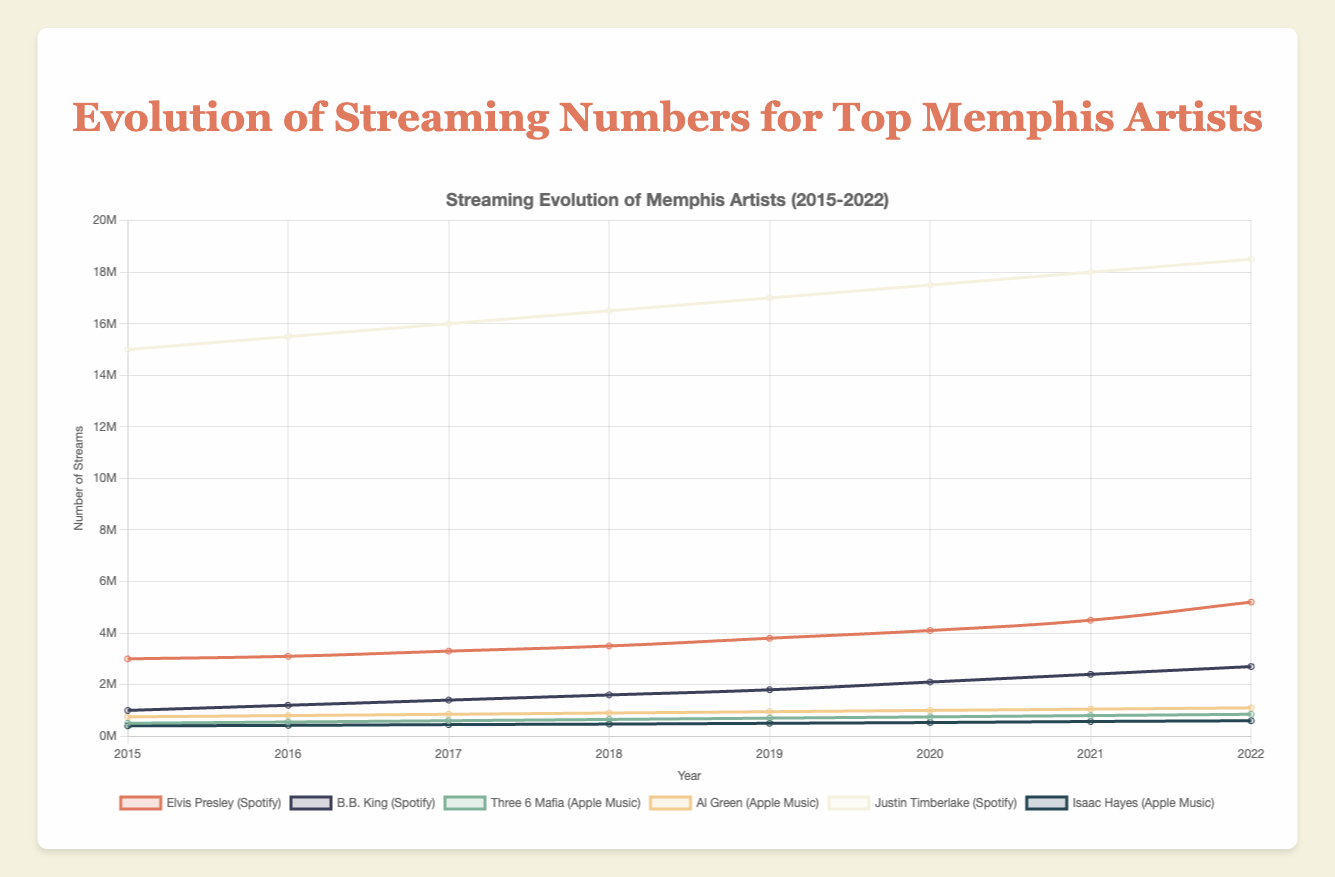How has Elvis Presley's streaming numbers on Spotify changed from 2015 to 2022? First, identify Elvis Presley's data on the chart. Then, look at the streaming numbers for each year from 2015 to 2022. The numbers show a consistent increase: from 3,000,000 in 2015 to 5,200,000 in 2022.
Answer: Increased Which artist had the highest number of streams on Spotify in 2022? Compare the streaming numbers in 2022 for all artists on Spotify. Justin Timberlake had the highest number of streams at 18,500,000.
Answer: Justin Timberlake Between B.B. King and Al Green, who experienced greater growth in streaming numbers from 2015 to 2022? Calculate the difference in streams between 2022 and 2015 for both artists. B.B. King went from 1,000,000 to 2,700,000 (growth of 1,700,000), while Al Green went from 750,000 to 1,100,000 (growth of 350,000). B.B. King experienced greater growth.
Answer: B.B. King What's the average streaming number for Justin Timberlake on Spotify from 2015 to 2022? Sum the streaming numbers for each year (15,000,000 + 15,500,000 + 16,000,000 + 16,500,000 + 17,000,000 + 17,500,000 + 18,000,000 + 18,500,000) which equals 134,000,000, then divide by the number of years (8). The average is 134,000,000 / 8 = 16,750,000.
Answer: 16,750,000 What is the general trend in streaming numbers for all the artists on the chart? Observe the lines representing each artist's streaming numbers from 2015 to 2022. All lines show an upward trend, indicating a general increase in streaming numbers over the years.
Answer: Upward trend 